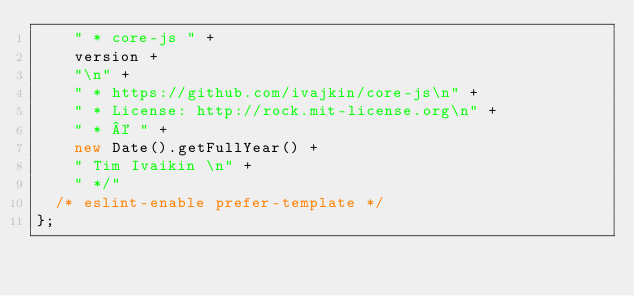Convert code to text. <code><loc_0><loc_0><loc_500><loc_500><_JavaScript_>    " * core-js " +
    version +
    "\n" +
    " * https://github.com/ivajkin/core-js\n" +
    " * License: http://rock.mit-license.org\n" +
    " * © " +
    new Date().getFullYear() +
    " Tim Ivaikin \n" +
    " */"
  /* eslint-enable prefer-template */
};
</code> 